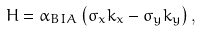Convert formula to latex. <formula><loc_0><loc_0><loc_500><loc_500>H = \alpha _ { B I A } \left ( \sigma _ { x } k _ { x } - \sigma _ { y } k _ { y } \right ) ,</formula> 